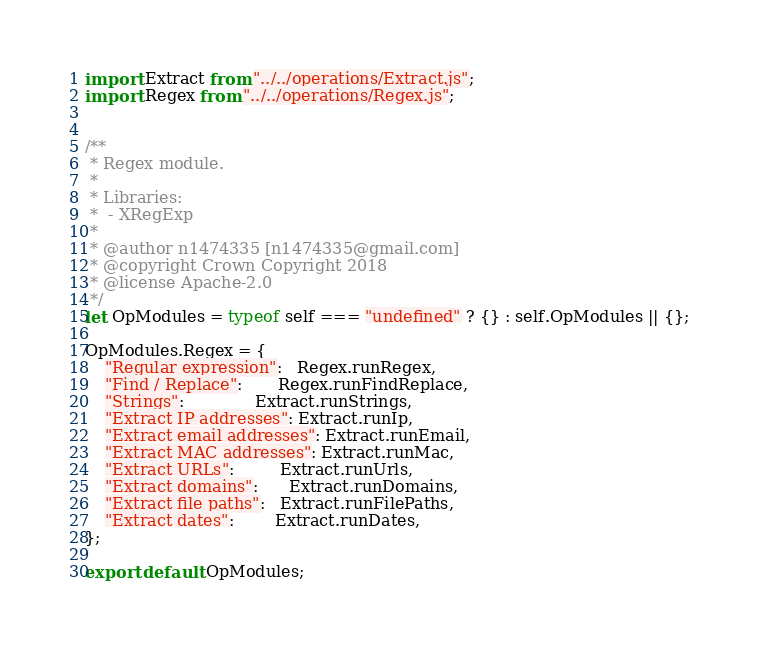Convert code to text. <code><loc_0><loc_0><loc_500><loc_500><_JavaScript_>import Extract from "../../operations/Extract.js";
import Regex from "../../operations/Regex.js";


/**
 * Regex module.
 *
 * Libraries:
 *  - XRegExp
 *
 * @author n1474335 [n1474335@gmail.com]
 * @copyright Crown Copyright 2018
 * @license Apache-2.0
 */
let OpModules = typeof self === "undefined" ? {} : self.OpModules || {};

OpModules.Regex = {
    "Regular expression":   Regex.runRegex,
    "Find / Replace":       Regex.runFindReplace,
    "Strings":              Extract.runStrings,
    "Extract IP addresses": Extract.runIp,
    "Extract email addresses": Extract.runEmail,
    "Extract MAC addresses": Extract.runMac,
    "Extract URLs":         Extract.runUrls,
    "Extract domains":      Extract.runDomains,
    "Extract file paths":   Extract.runFilePaths,
    "Extract dates":        Extract.runDates,
};

export default OpModules;
</code> 